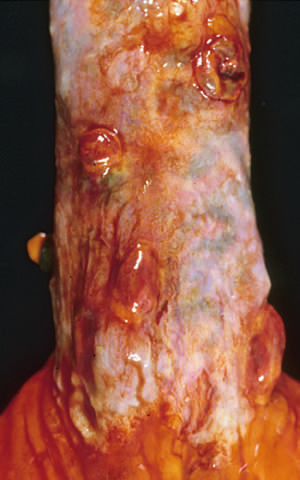what are present in this postmortem specimen corresponding to the angiogram in the figure?
Answer the question using a single word or phrase. Collapsed varices 